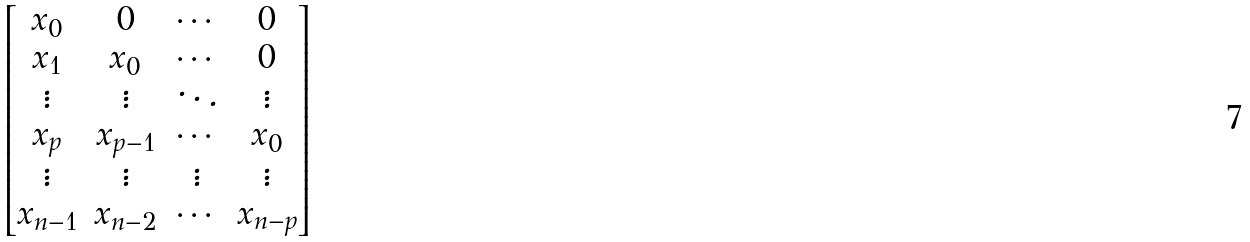<formula> <loc_0><loc_0><loc_500><loc_500>\begin{bmatrix} x _ { 0 } & 0 & \cdots & 0 \\ x _ { 1 } & x _ { 0 } & \cdots & 0 \\ \vdots & \vdots & \ddots & \vdots \\ x _ { p } & x _ { p - 1 } & \cdots & x _ { 0 } \\ \vdots & \vdots & \vdots & \vdots \\ x _ { n - 1 } & x _ { n - 2 } & \cdots & x _ { n - p } \end{bmatrix}</formula> 